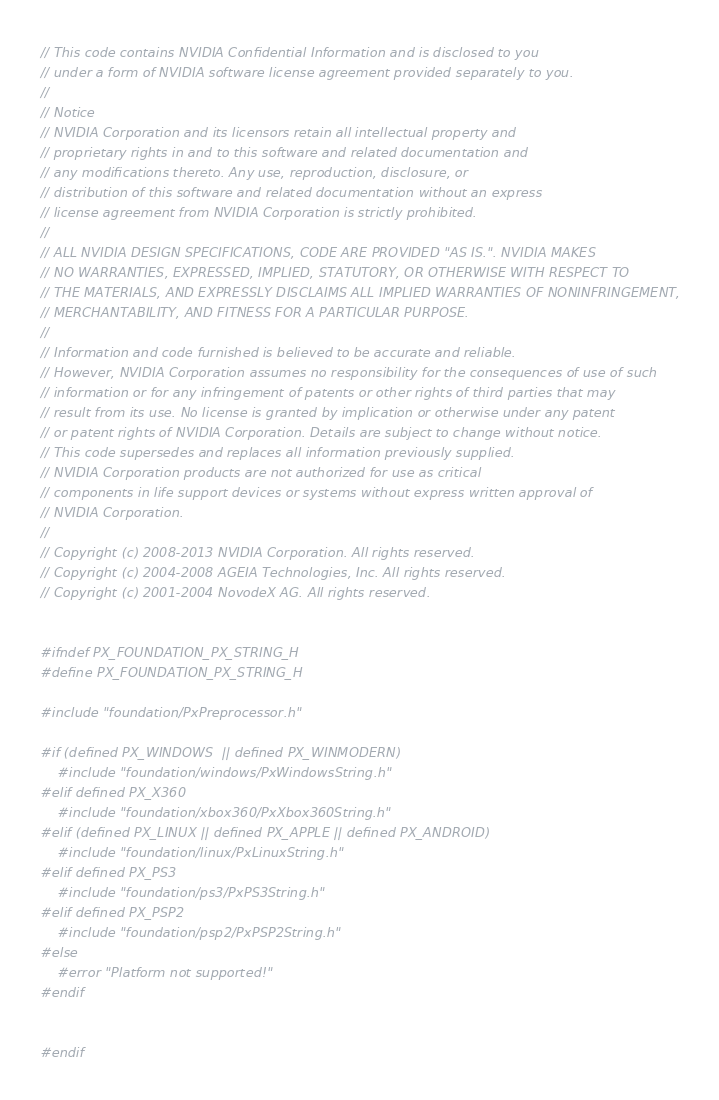Convert code to text. <code><loc_0><loc_0><loc_500><loc_500><_C_>// This code contains NVIDIA Confidential Information and is disclosed to you
// under a form of NVIDIA software license agreement provided separately to you.
//
// Notice
// NVIDIA Corporation and its licensors retain all intellectual property and
// proprietary rights in and to this software and related documentation and
// any modifications thereto. Any use, reproduction, disclosure, or
// distribution of this software and related documentation without an express
// license agreement from NVIDIA Corporation is strictly prohibited.
//
// ALL NVIDIA DESIGN SPECIFICATIONS, CODE ARE PROVIDED "AS IS.". NVIDIA MAKES
// NO WARRANTIES, EXPRESSED, IMPLIED, STATUTORY, OR OTHERWISE WITH RESPECT TO
// THE MATERIALS, AND EXPRESSLY DISCLAIMS ALL IMPLIED WARRANTIES OF NONINFRINGEMENT,
// MERCHANTABILITY, AND FITNESS FOR A PARTICULAR PURPOSE.
//
// Information and code furnished is believed to be accurate and reliable.
// However, NVIDIA Corporation assumes no responsibility for the consequences of use of such
// information or for any infringement of patents or other rights of third parties that may
// result from its use. No license is granted by implication or otherwise under any patent
// or patent rights of NVIDIA Corporation. Details are subject to change without notice.
// This code supersedes and replaces all information previously supplied.
// NVIDIA Corporation products are not authorized for use as critical
// components in life support devices or systems without express written approval of
// NVIDIA Corporation.
//
// Copyright (c) 2008-2013 NVIDIA Corporation. All rights reserved.
// Copyright (c) 2004-2008 AGEIA Technologies, Inc. All rights reserved.
// Copyright (c) 2001-2004 NovodeX AG. All rights reserved.  


#ifndef PX_FOUNDATION_PX_STRING_H
#define PX_FOUNDATION_PX_STRING_H

#include "foundation/PxPreprocessor.h"

#if (defined PX_WINDOWS  || defined PX_WINMODERN)
	#include "foundation/windows/PxWindowsString.h"
#elif defined PX_X360
	#include "foundation/xbox360/PxXbox360String.h"
#elif (defined PX_LINUX || defined PX_APPLE || defined PX_ANDROID)
	#include "foundation/linux/PxLinuxString.h"
#elif defined PX_PS3
	#include "foundation/ps3/PxPS3String.h"
#elif defined PX_PSP2
	#include "foundation/psp2/PxPSP2String.h"
#else
	#error "Platform not supported!"
#endif


#endif
</code> 